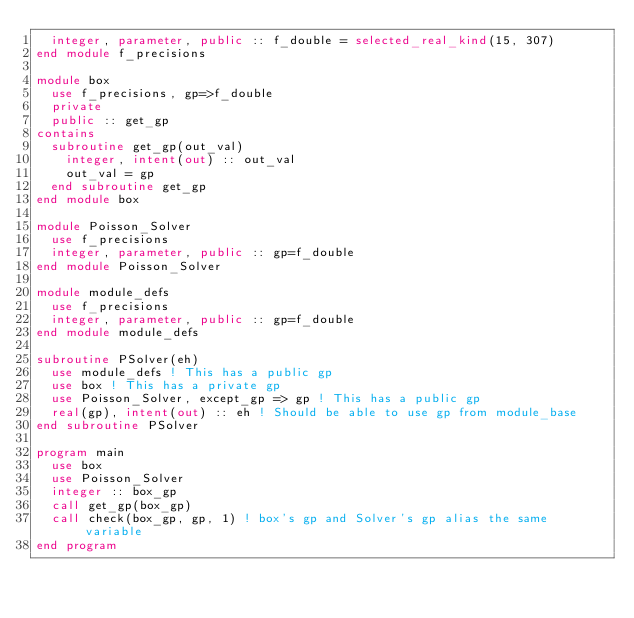<code> <loc_0><loc_0><loc_500><loc_500><_FORTRAN_>  integer, parameter, public :: f_double = selected_real_kind(15, 307)
end module f_precisions

module box
  use f_precisions, gp=>f_double
  private
  public :: get_gp
contains
  subroutine get_gp(out_val)
    integer, intent(out) :: out_val
    out_val = gp
  end subroutine get_gp
end module box

module Poisson_Solver
  use f_precisions
  integer, parameter, public :: gp=f_double
end module Poisson_Solver

module module_defs
  use f_precisions
  integer, parameter, public :: gp=f_double
end module module_defs

subroutine PSolver(eh)
  use module_defs ! This has a public gp
  use box ! This has a private gp
  use Poisson_Solver, except_gp => gp ! This has a public gp
  real(gp), intent(out) :: eh ! Should be able to use gp from module_base
end subroutine PSolver

program main
  use box
  use Poisson_Solver
  integer :: box_gp
  call get_gp(box_gp)
  call check(box_gp, gp, 1) ! box's gp and Solver's gp alias the same variable
end program
</code> 